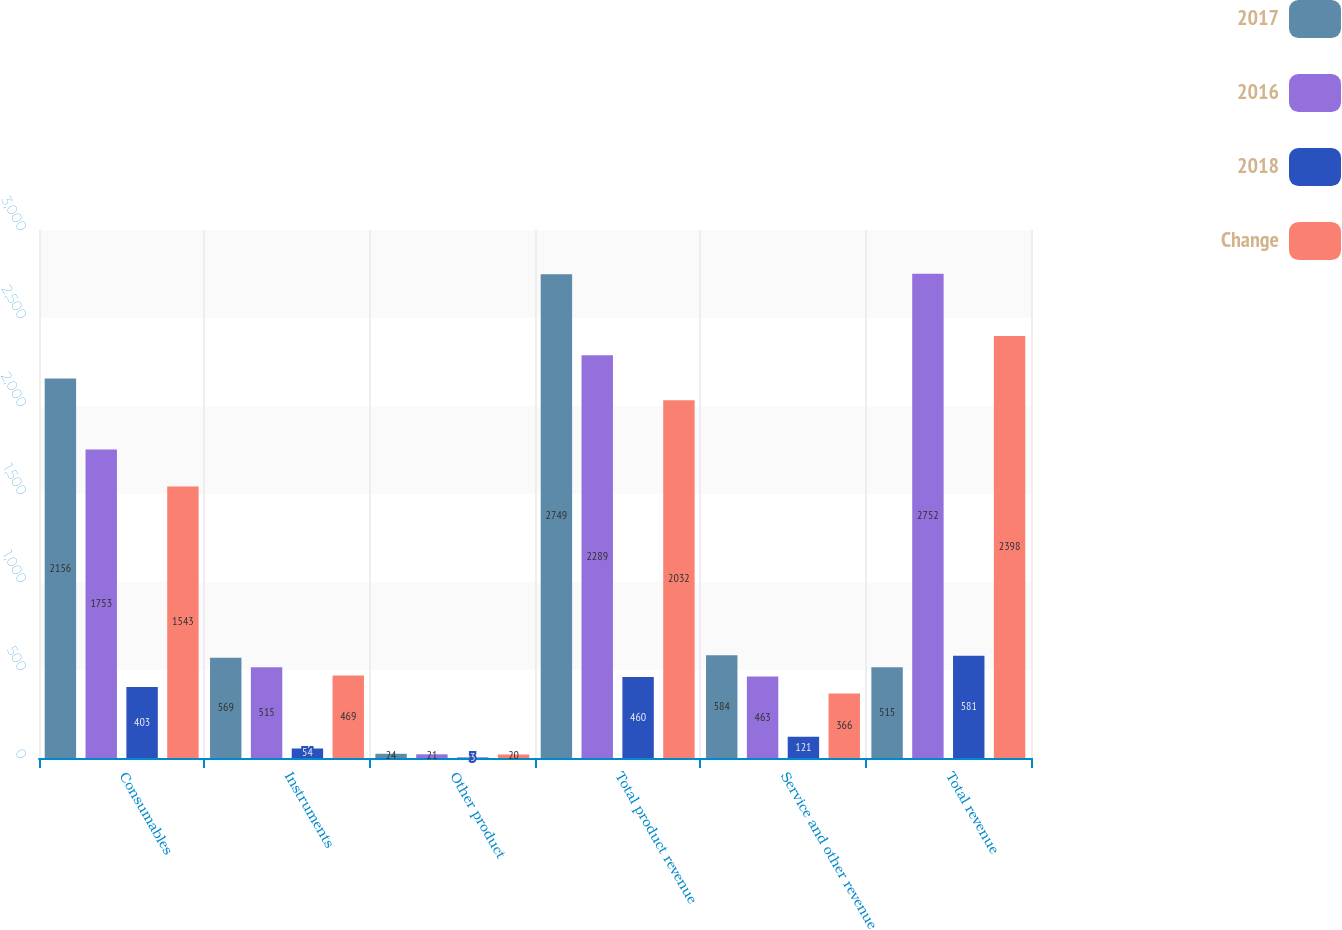<chart> <loc_0><loc_0><loc_500><loc_500><stacked_bar_chart><ecel><fcel>Consumables<fcel>Instruments<fcel>Other product<fcel>Total product revenue<fcel>Service and other revenue<fcel>Total revenue<nl><fcel>2017<fcel>2156<fcel>569<fcel>24<fcel>2749<fcel>584<fcel>515<nl><fcel>2016<fcel>1753<fcel>515<fcel>21<fcel>2289<fcel>463<fcel>2752<nl><fcel>2018<fcel>403<fcel>54<fcel>3<fcel>460<fcel>121<fcel>581<nl><fcel>Change<fcel>1543<fcel>469<fcel>20<fcel>2032<fcel>366<fcel>2398<nl></chart> 